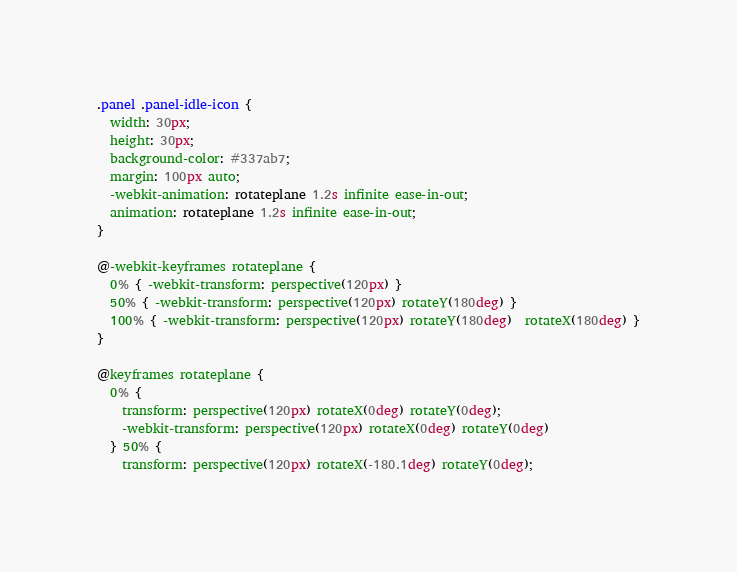<code> <loc_0><loc_0><loc_500><loc_500><_CSS_>
.panel .panel-idle-icon {
  width: 30px;
  height: 30px;
  background-color: #337ab7;
  margin: 100px auto;
  -webkit-animation: rotateplane 1.2s infinite ease-in-out;
  animation: rotateplane 1.2s infinite ease-in-out;
}

@-webkit-keyframes rotateplane {
  0% { -webkit-transform: perspective(120px) }
  50% { -webkit-transform: perspective(120px) rotateY(180deg) }
  100% { -webkit-transform: perspective(120px) rotateY(180deg)  rotateX(180deg) }
}

@keyframes rotateplane {
  0% { 
    transform: perspective(120px) rotateX(0deg) rotateY(0deg);
    -webkit-transform: perspective(120px) rotateX(0deg) rotateY(0deg) 
  } 50% { 
    transform: perspective(120px) rotateX(-180.1deg) rotateY(0deg);</code> 